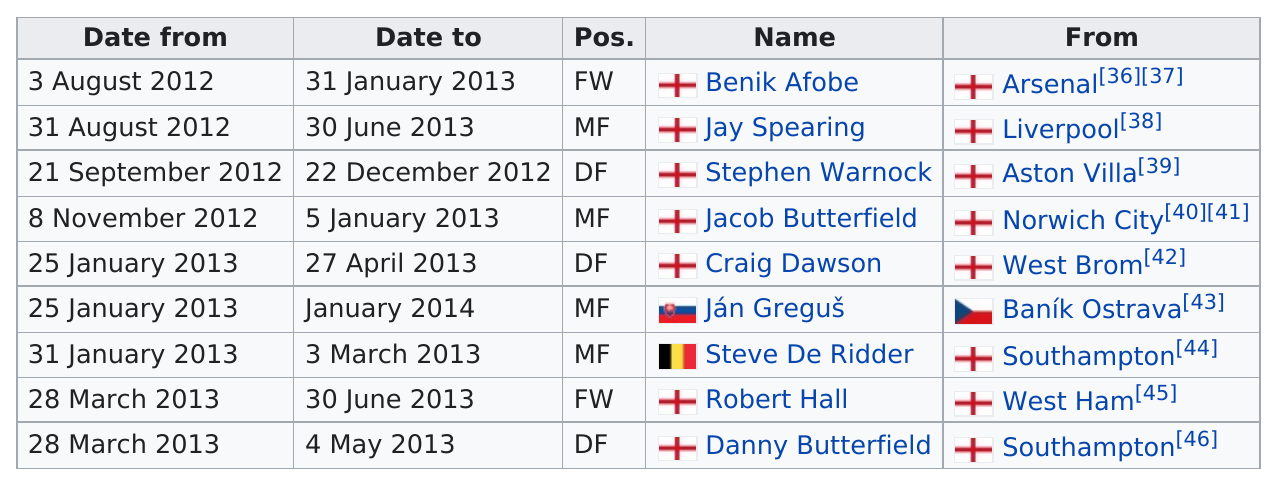Indicate a few pertinent items in this graphic. Ján Greguš spent the most time as a loan. Name a player who did not have a position of 'forward': Jay Spearing. The player whose "to" date is in March and "from" date is in January is Steve De Ridder. Jacob Butterfield's previous loan was held by Stephen Warnock. England had the most players loaned out, making it the country with the largest number of players on loan. 